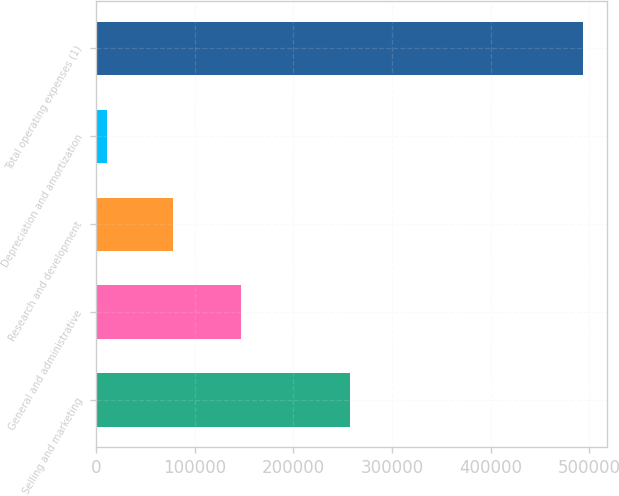Convert chart to OTSL. <chart><loc_0><loc_0><loc_500><loc_500><bar_chart><fcel>Selling and marketing<fcel>General and administrative<fcel>Research and development<fcel>Depreciation and amortization<fcel>Total operating expenses (1)<nl><fcel>257329<fcel>147260<fcel>78184<fcel>10634<fcel>493407<nl></chart> 